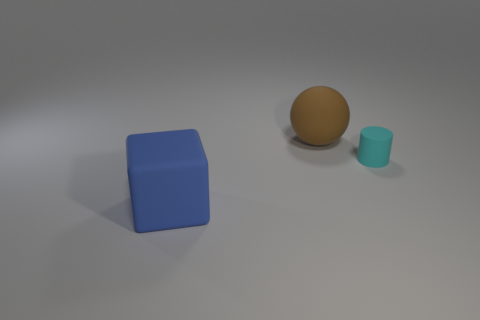Do the big rubber thing that is on the right side of the large cube and the tiny cylinder have the same color?
Your answer should be compact. No. There is a large ball that is made of the same material as the tiny cylinder; what is its color?
Provide a succinct answer. Brown. Do the matte cube and the ball have the same size?
Make the answer very short. Yes. What material is the big sphere?
Keep it short and to the point. Rubber. What is the material of the brown object that is the same size as the block?
Offer a terse response. Rubber. Are there any brown matte things of the same size as the block?
Your answer should be compact. Yes. Are there the same number of large brown objects that are to the right of the cyan cylinder and large brown spheres that are left of the big blue thing?
Your response must be concise. Yes. Is the number of gray rubber cylinders greater than the number of balls?
Your response must be concise. No. What number of shiny objects are tiny purple cylinders or small cyan cylinders?
Provide a short and direct response. 0. What number of big objects are the same color as the tiny rubber thing?
Your response must be concise. 0. 